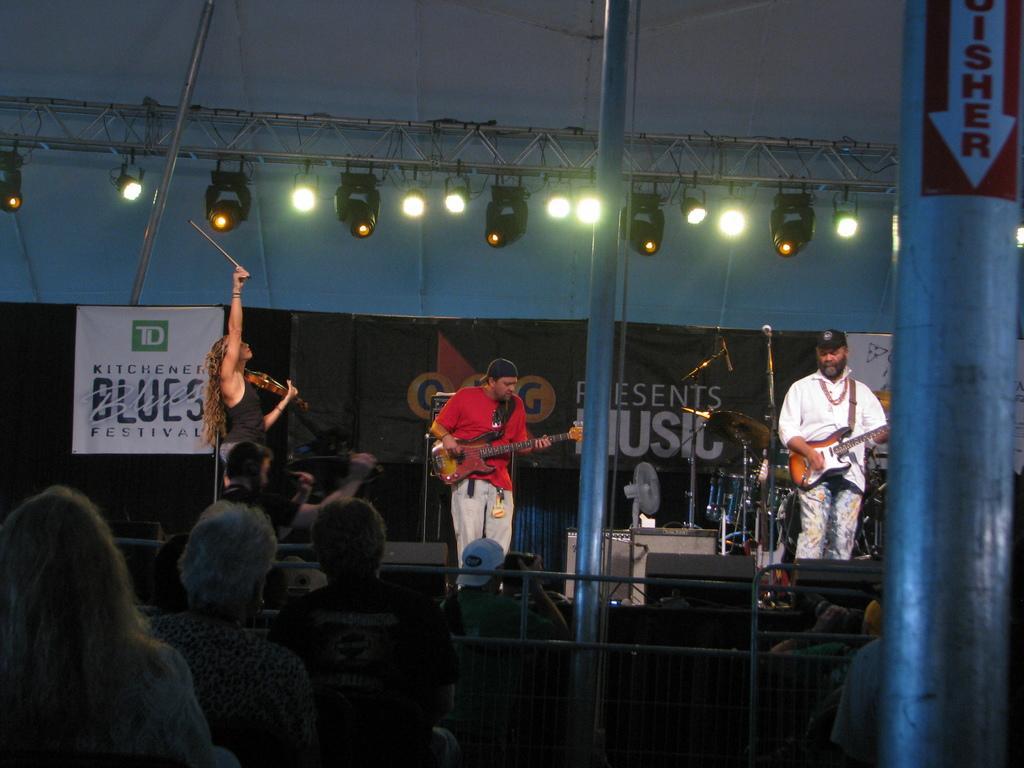Could you give a brief overview of what you see in this image? It is a music concert, there are total three people on the stage holding guitar in their hand behind them there are other drums , a table fan. In front of these people there are some audience sitting in the background there is a banner and some other lights. 